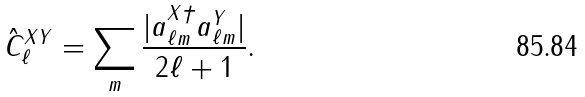<formula> <loc_0><loc_0><loc_500><loc_500>\hat { C } _ { \ell } ^ { X Y } = \sum _ { m } \frac { | a _ { \ell m } ^ { X \dagger } a _ { \ell m } ^ { Y } | } { 2 \ell + 1 } .</formula> 